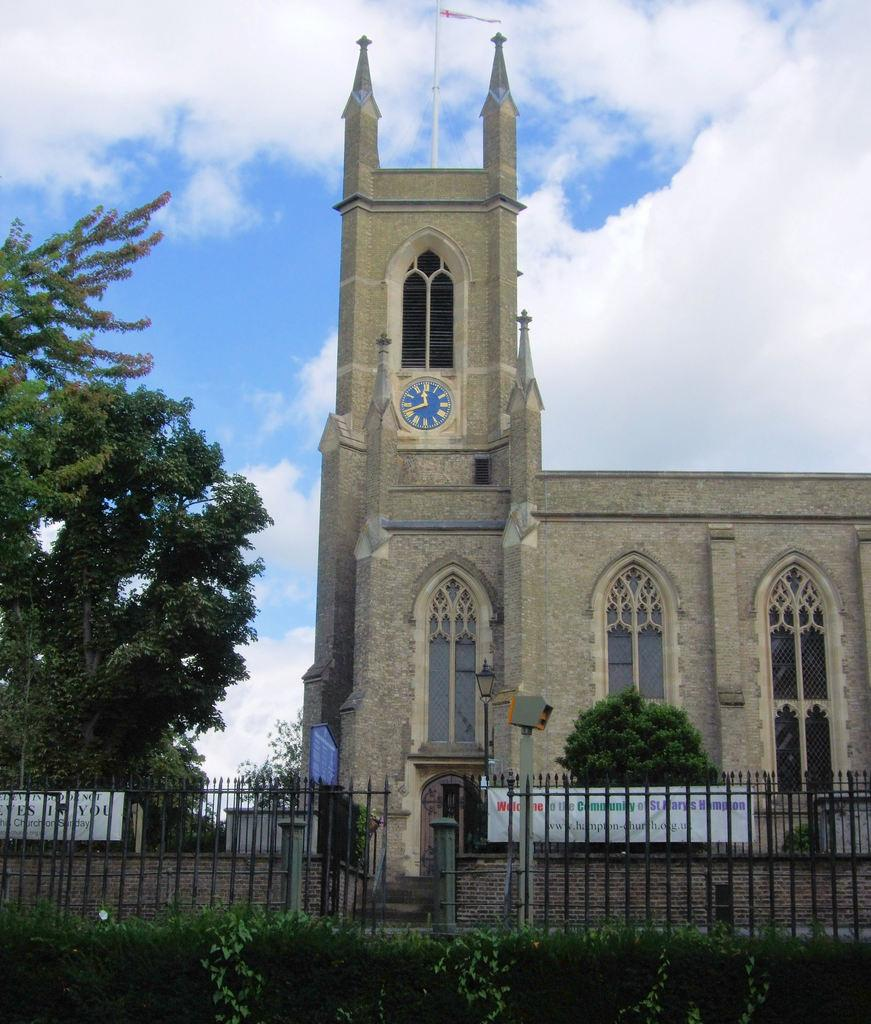What is located at the bottom of the image? There are plants and a fence at the bottom of the image. What can be seen in the background of the image? There is a building, windows, hoardings, trees, a clock on a wall, a flag, and clouds in the sky in the background of the image. Can you tell me how many family members are present in the image? There is no family present in the image; it features plants, a fence, and various elements in the background. What type of agreement is being discussed in the image? There is no discussion or agreement present in the image; it is a still image of plants, a fence, and various elements in the background. 